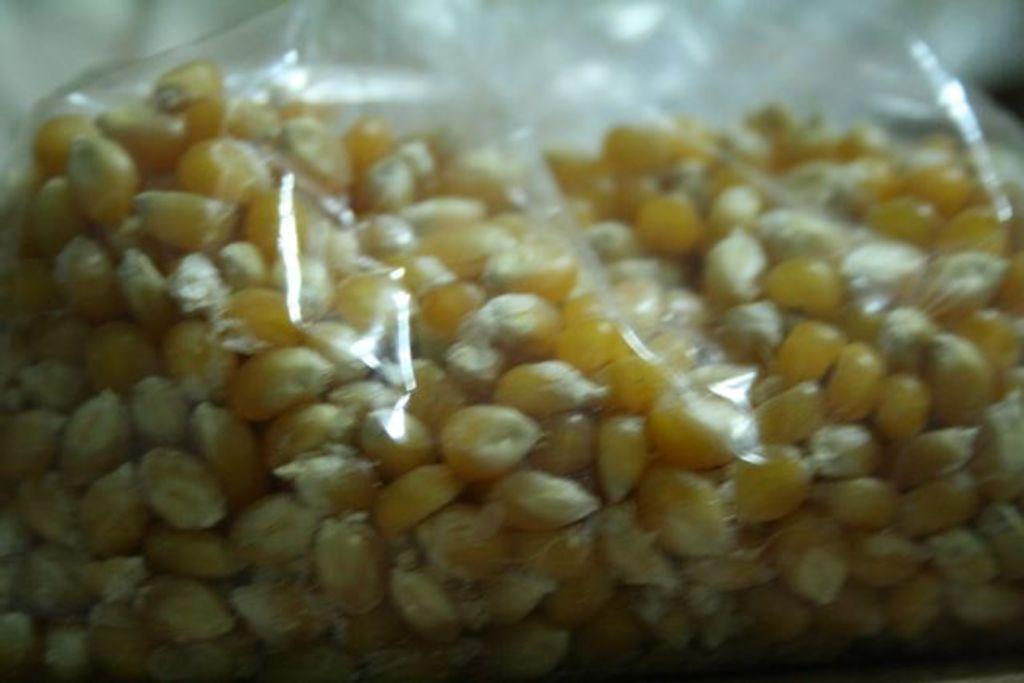Can you describe this image briefly? In this image we can see corn in the packet. 